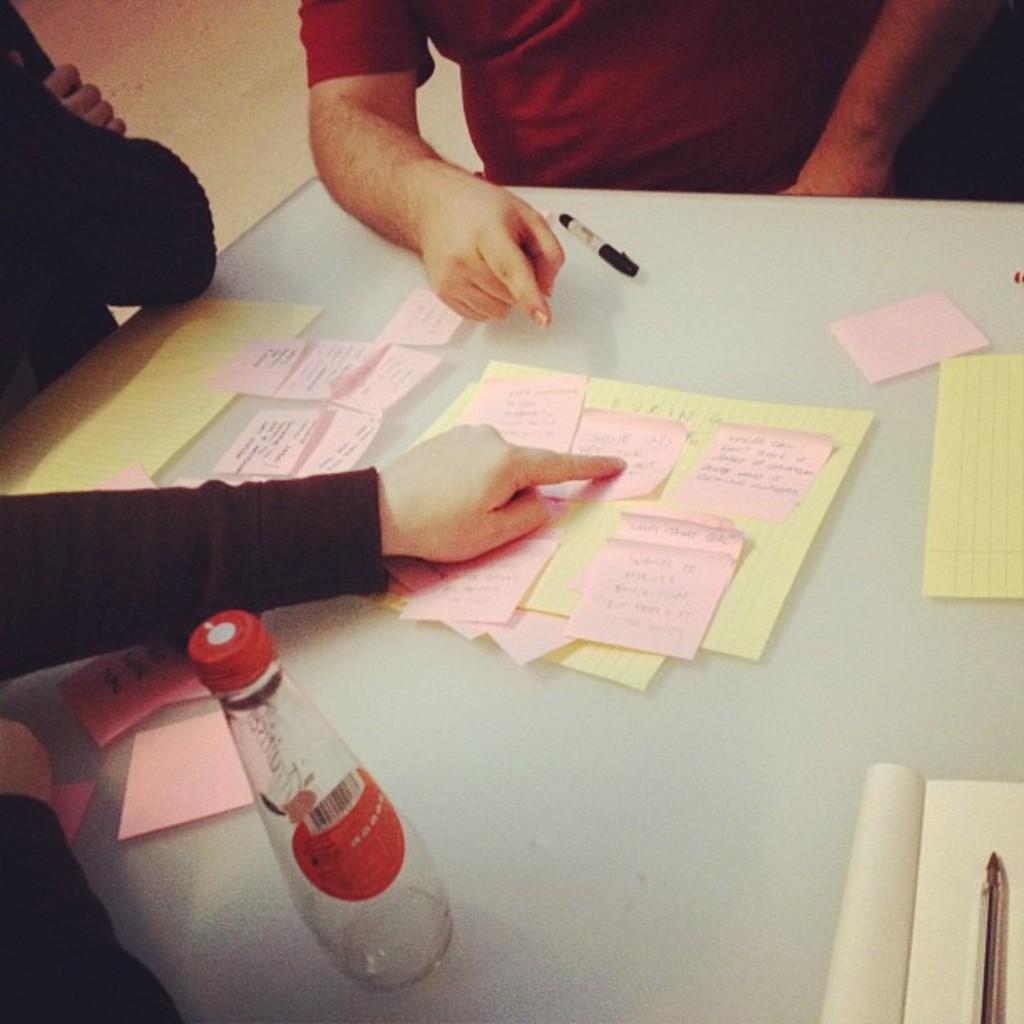Please provide a concise description of this image. In the middle there is a table on that table there is a bottle,paper,book and pen. At the top there is a man he wear red t shirt. On the left there is a person. 